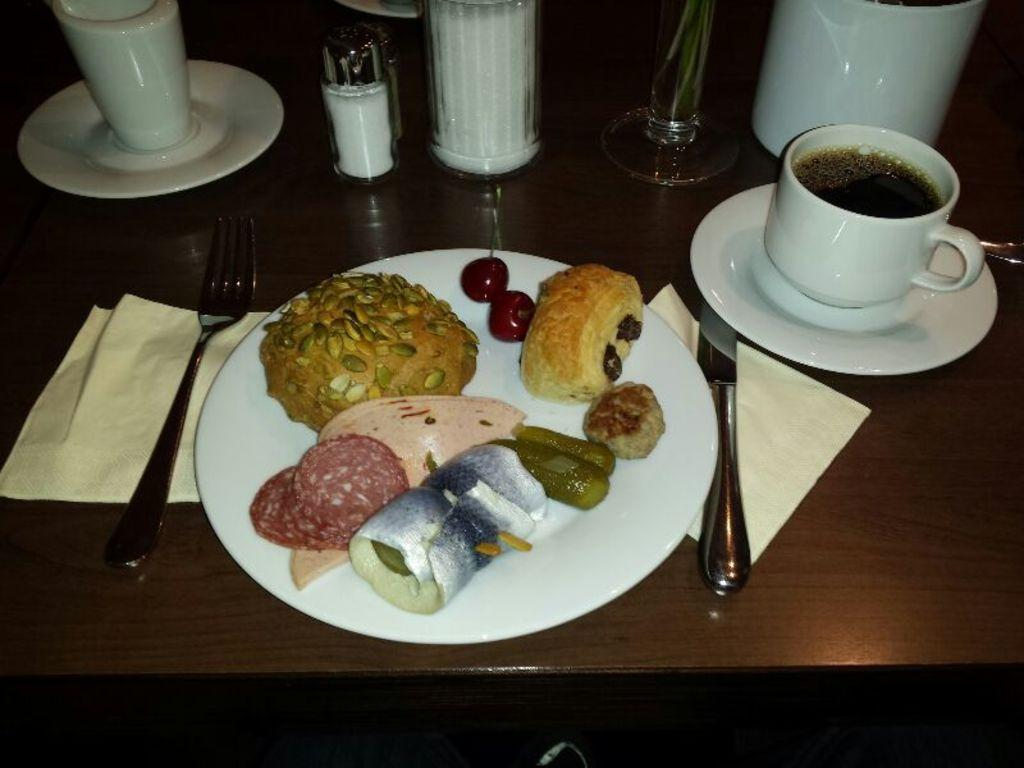What is on the plate in the image? There are different types of food in a plate in the image. What utensils are visible in the image? A knife and a fork are visible in the image. What is the glass in the image used for? The glass in the image is likely used for drinking. What beverage is present in the image? There is a cup of tea in the image. What might be used for cleaning or wiping in the image? Napkins are in the image for cleaning or wiping. What type of caption is written on the band's shirt in the image? There is no band or shirt with a caption present in the image; it features a plate of food and related items. 